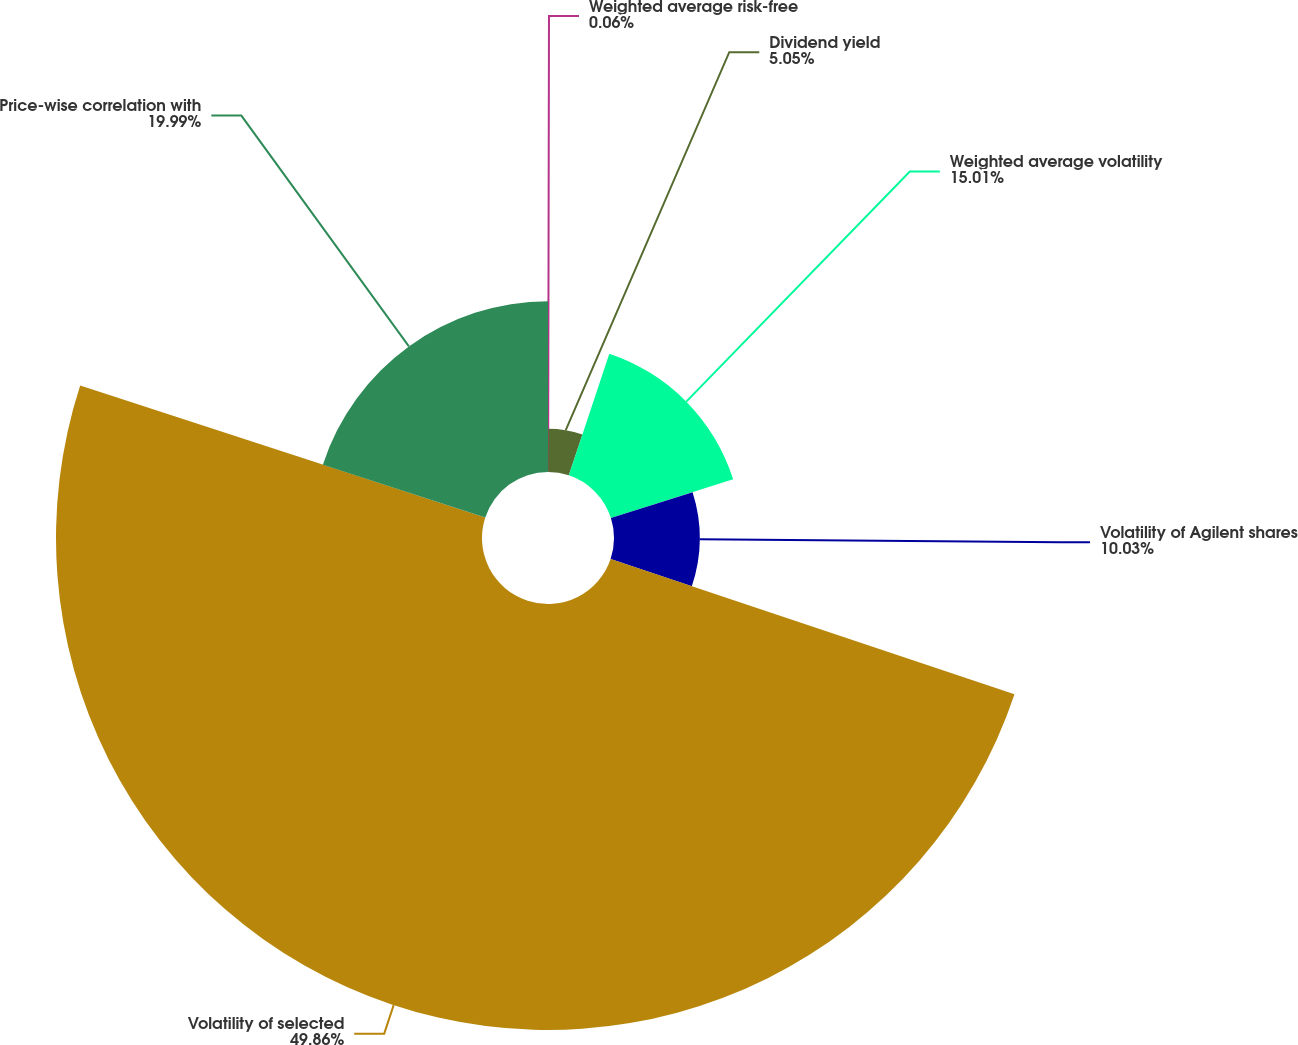Convert chart. <chart><loc_0><loc_0><loc_500><loc_500><pie_chart><fcel>Weighted average risk-free<fcel>Dividend yield<fcel>Weighted average volatility<fcel>Volatility of Agilent shares<fcel>Volatility of selected<fcel>Price-wise correlation with<nl><fcel>0.06%<fcel>5.05%<fcel>15.01%<fcel>10.03%<fcel>49.87%<fcel>19.99%<nl></chart> 